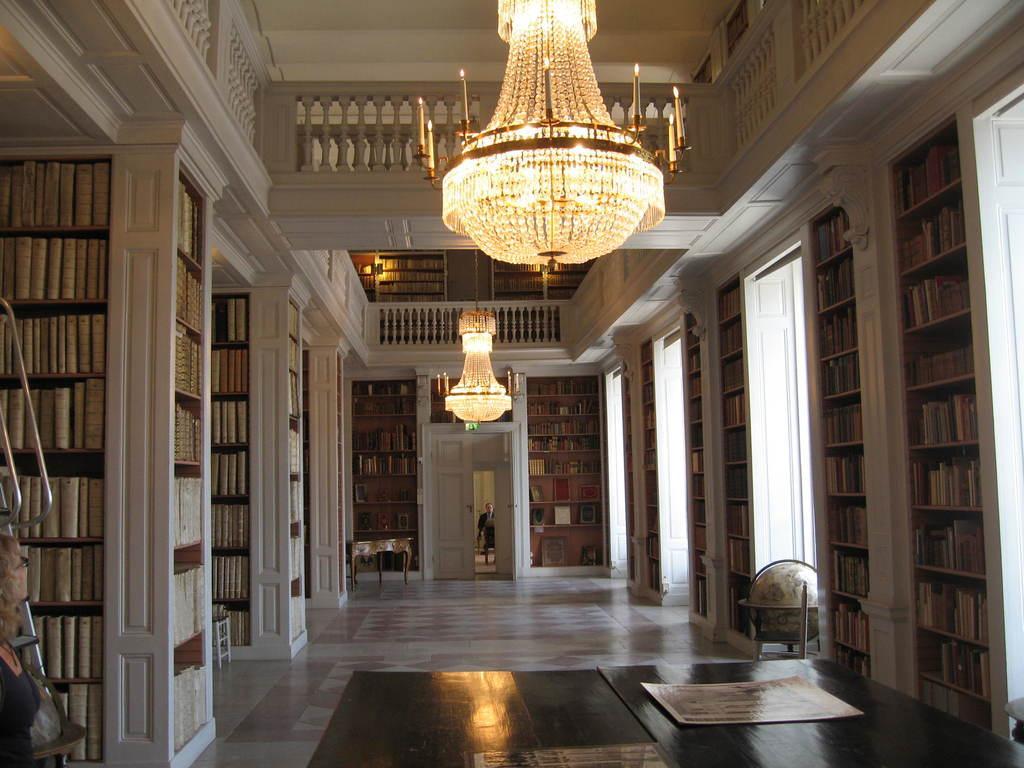Could you give a brief overview of what you see in this image? in this image we can see books arranged in a shelves, lights, person, doors, table and floor. 